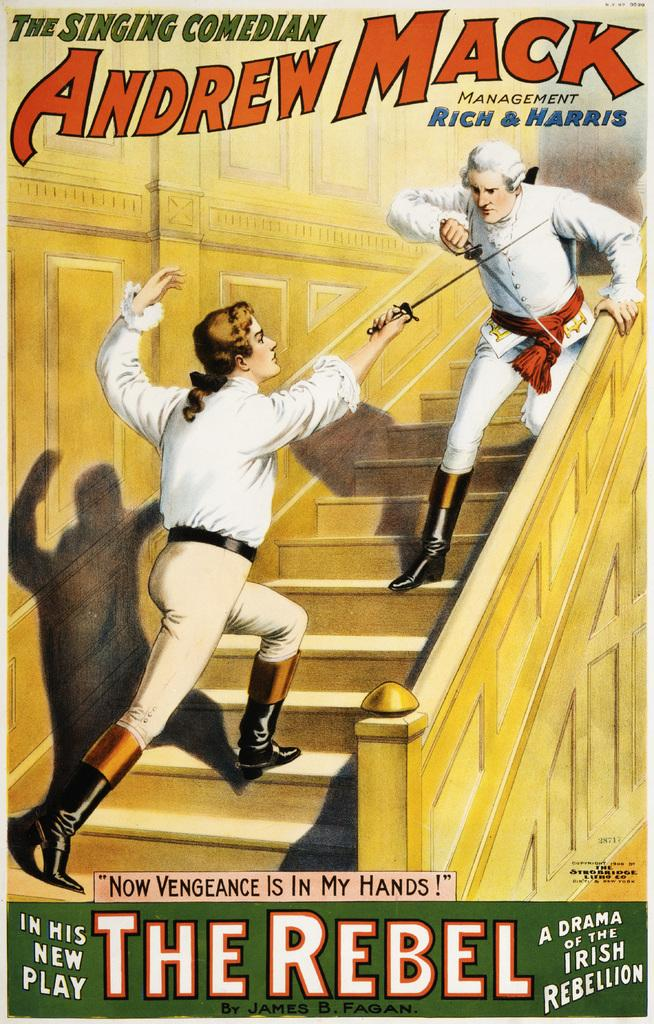<image>
Give a short and clear explanation of the subsequent image. two men fencing on the stairs as an advertisement for The Rebel 